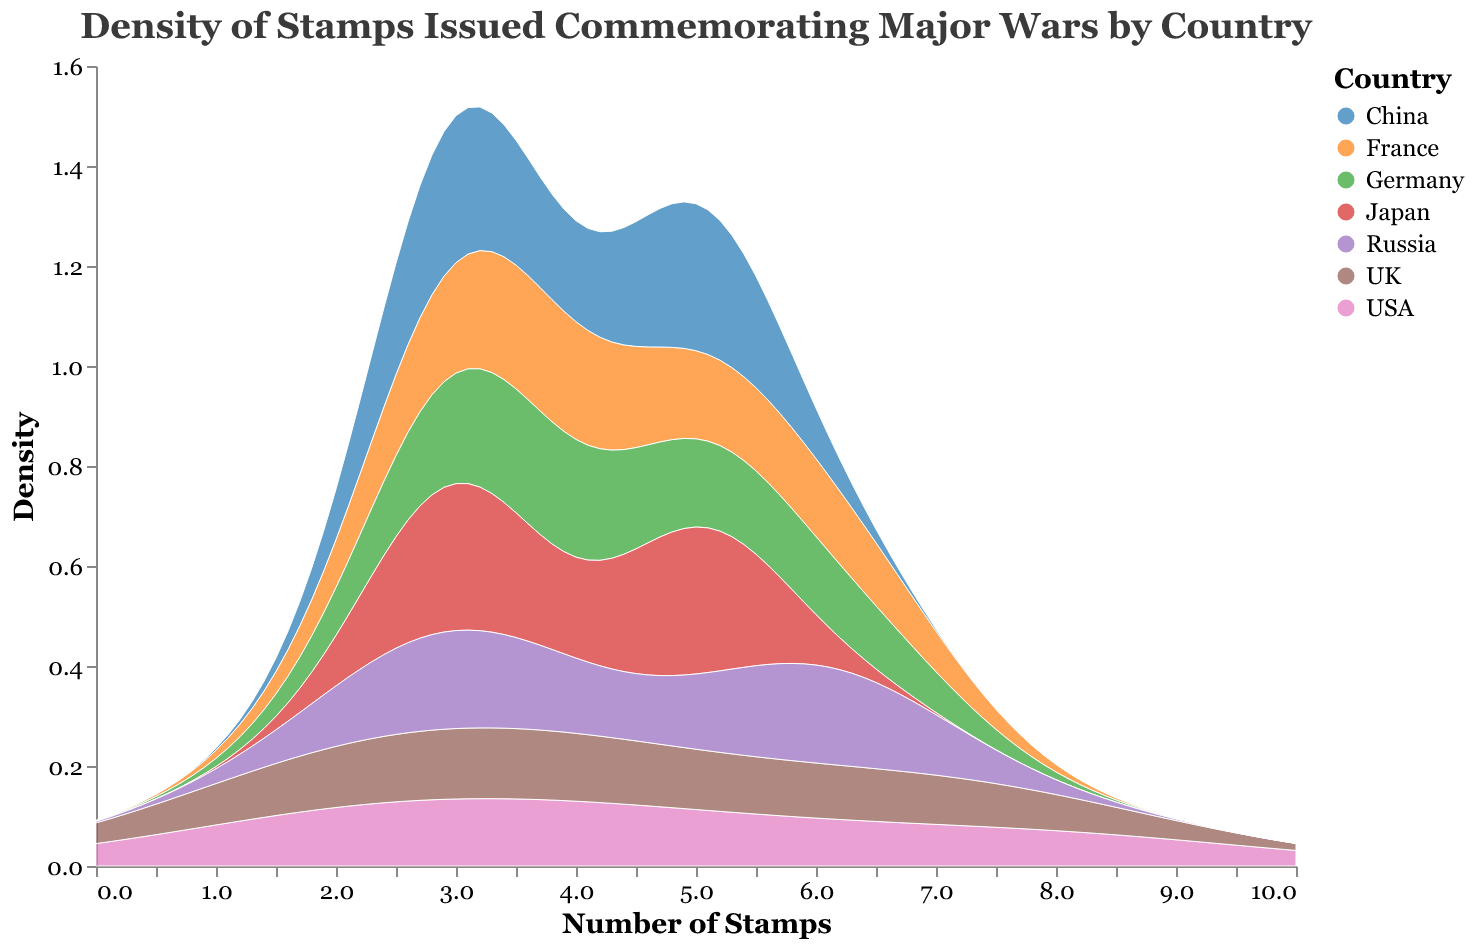What is the title of the plot? The title is displayed at the top of the plot and reads, "Density of Stamps Issued Commemorating Major Wars by Country."
Answer: Density of Stamps Issued Commemorating Major Wars by Country How many countries are represented in the plot? There are seven countries mentioned in the legend on the right side of the plot.
Answer: Seven Which country has the highest density peak in the plot? By examining the density peaks, we can see which country has the highest value along the y-axis. The USA appears to have the highest peak.
Answer: USA What color is used to represent France in the plot? The legend on the right side of the plot provides color coding for each country. France is represented by a specific color according to this legend.
Answer: Blue (assuming from the common "category10" color scheme) What is the general trend for the density of stamps between 0 to 10 stamps? Observing the density plot from 0 to 10 along the x-axis, different countries show different density distributions, but generally, higher densities occur around 3-6 stamps.
Answer: Higher densities around 3-6 stamps Which year has the highest number of stamps issued by the USA, according to the plot? Although the exact years are not explicitly shown on a density plot, we know that density plots reflect overall distributions from the historical data. The peak of the USA's density likely reflects the year 1945 with 8 stamps, as noted in the data.
Answer: 1945 Compare the density of stamps issued by Germany and the UK. Which country shows a peak at a higher number of stamps? Observing the density curves for Germany and the UK shows their respective peaks. Germany’s curve peaks at a density of 6 stamps, whereas the UK’s curve peaks higher around 7 stamps.
Answer: UK What is the general distribution pattern of stamps issued by Japan? The density plot of Japan should show the distribution around the number of stamps. The peak densities will provide insight. From the plot, Japan appears to have notable peaks around 5 stamps.
Answer: Peaks around 5 stamps How does the distribution of stamps issued by Russia compare to that of China? Looking at the density plots for Russia and China, we can compare their peaks and general distribution. Both seem to be similar, with peaks around 5-6 stamps.
Answer: Similar distributions, peaks around 5-6 stamps 